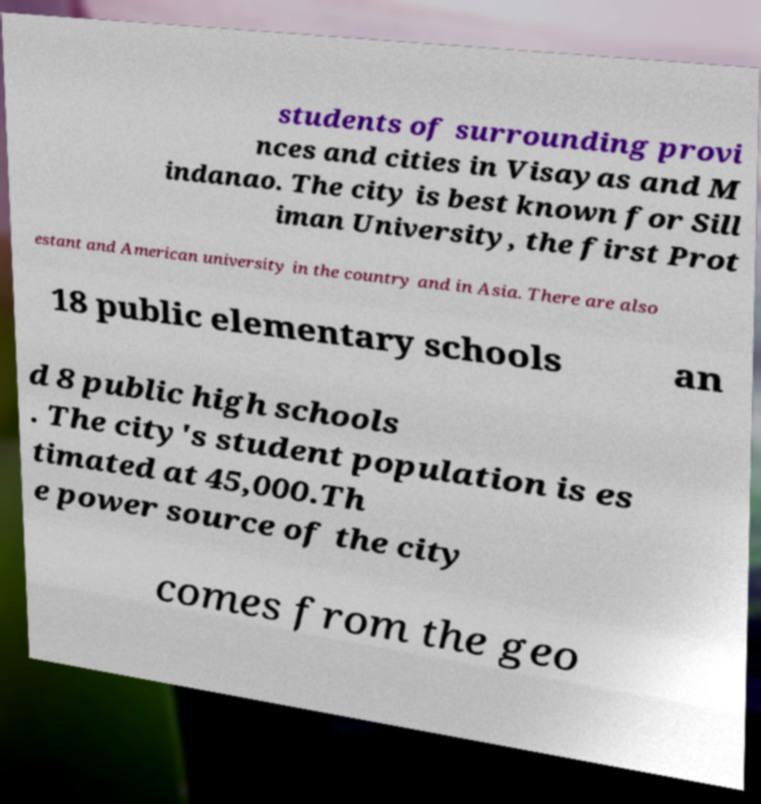I need the written content from this picture converted into text. Can you do that? students of surrounding provi nces and cities in Visayas and M indanao. The city is best known for Sill iman University, the first Prot estant and American university in the country and in Asia. There are also 18 public elementary schools an d 8 public high schools . The city's student population is es timated at 45,000.Th e power source of the city comes from the geo 